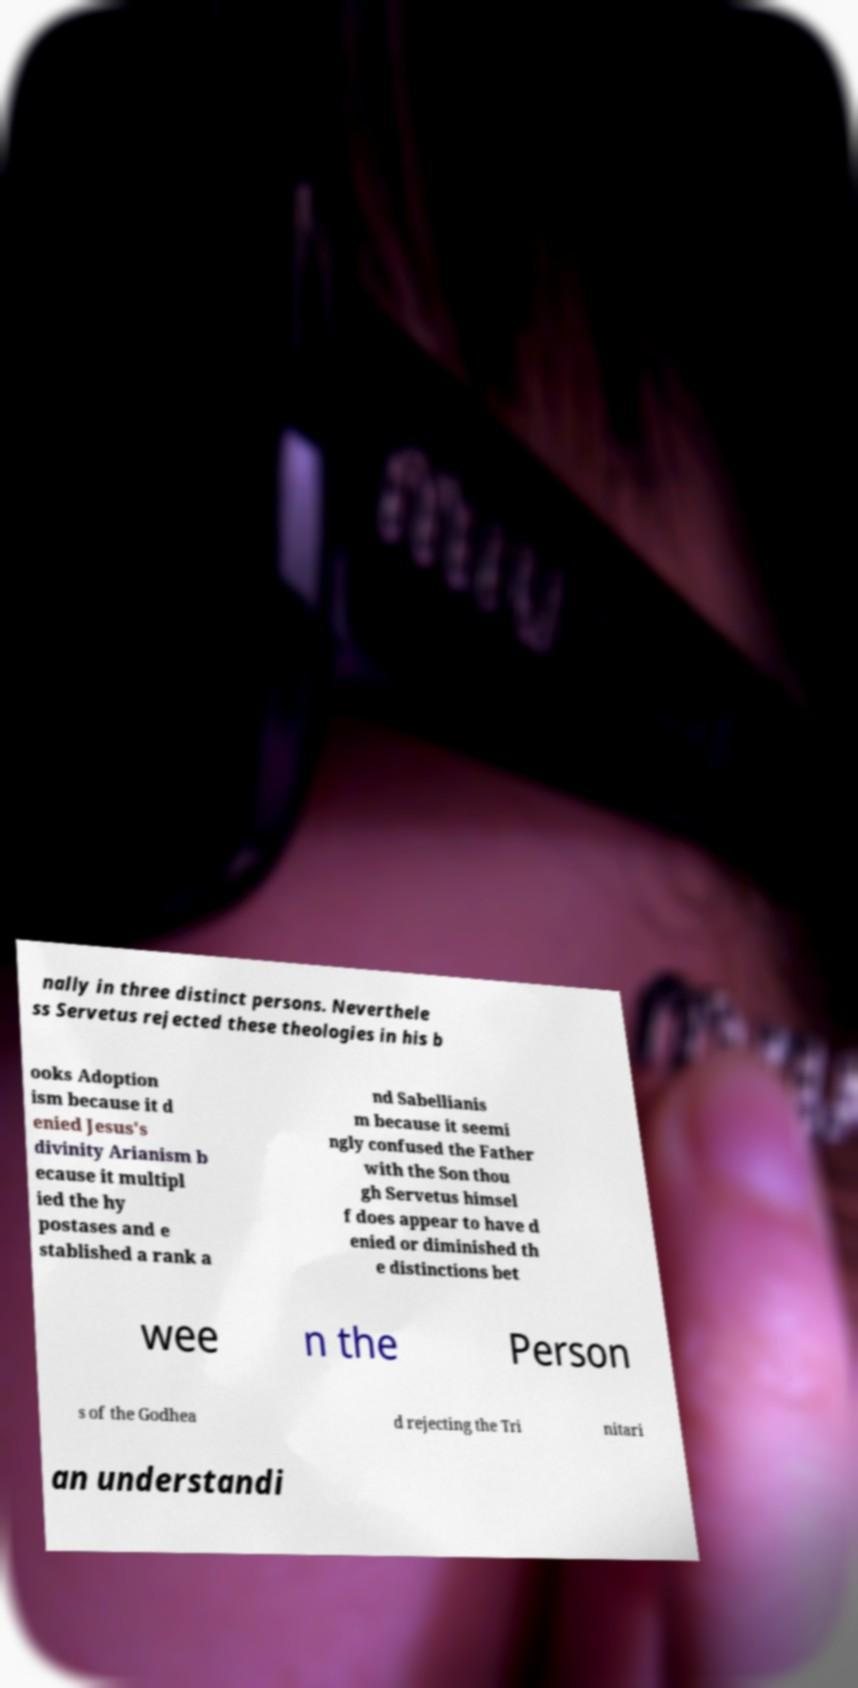Can you read and provide the text displayed in the image?This photo seems to have some interesting text. Can you extract and type it out for me? nally in three distinct persons. Neverthele ss Servetus rejected these theologies in his b ooks Adoption ism because it d enied Jesus's divinity Arianism b ecause it multipl ied the hy postases and e stablished a rank a nd Sabellianis m because it seemi ngly confused the Father with the Son thou gh Servetus himsel f does appear to have d enied or diminished th e distinctions bet wee n the Person s of the Godhea d rejecting the Tri nitari an understandi 